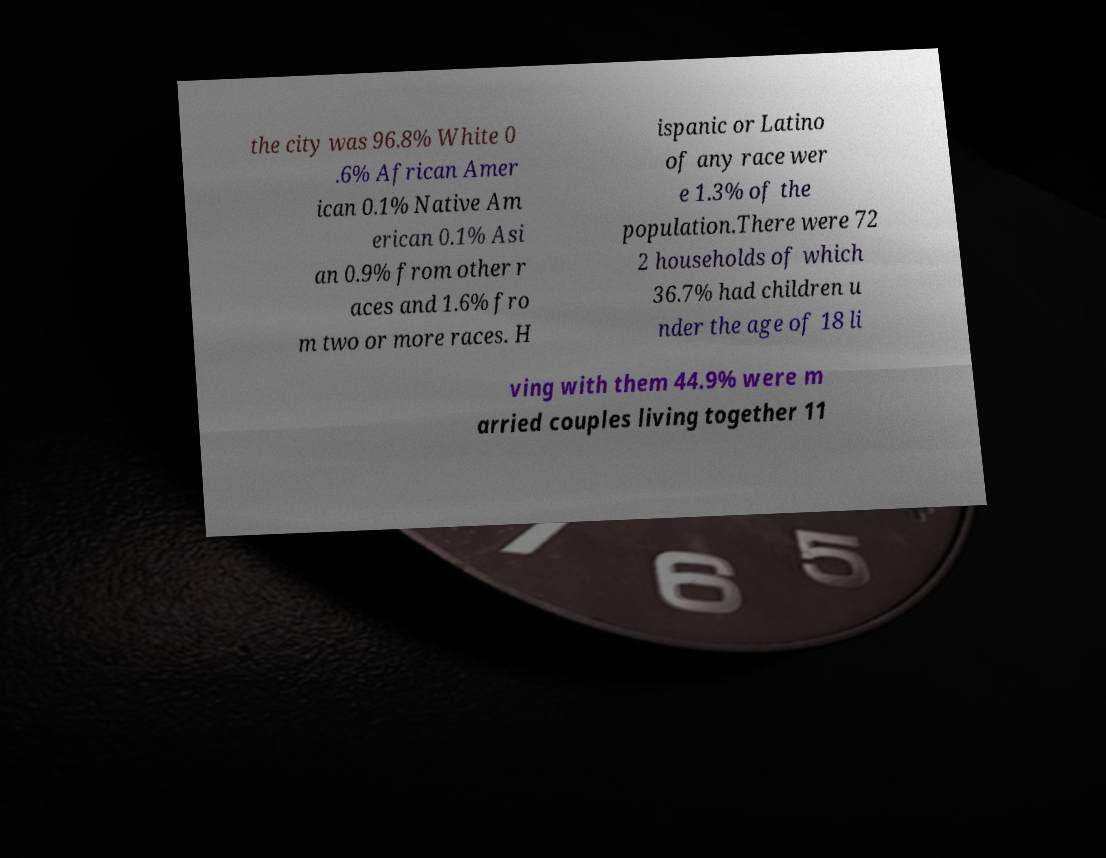For documentation purposes, I need the text within this image transcribed. Could you provide that? the city was 96.8% White 0 .6% African Amer ican 0.1% Native Am erican 0.1% Asi an 0.9% from other r aces and 1.6% fro m two or more races. H ispanic or Latino of any race wer e 1.3% of the population.There were 72 2 households of which 36.7% had children u nder the age of 18 li ving with them 44.9% were m arried couples living together 11 